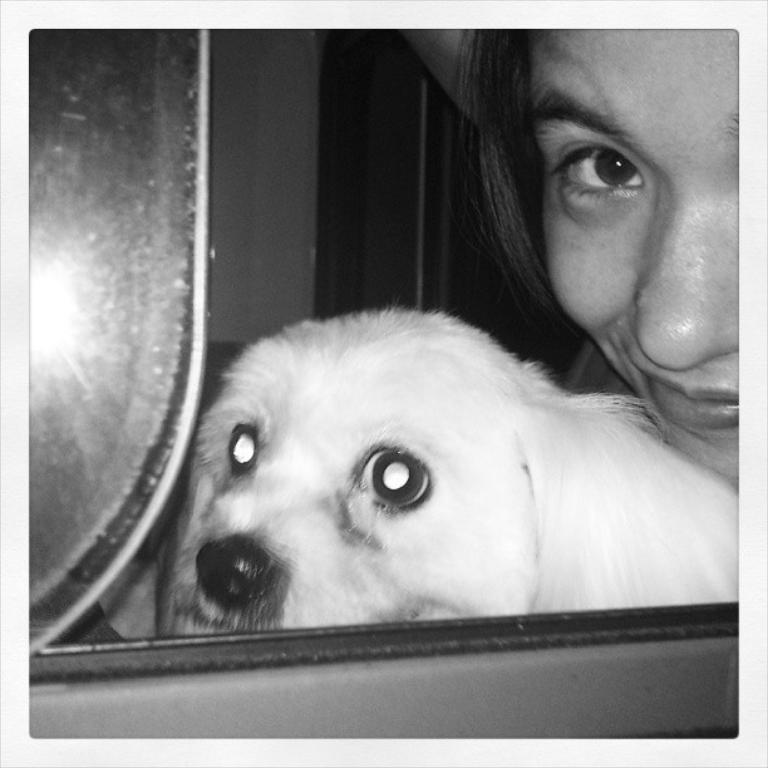What is the color scheme of the picture? The picture is black and white. What type of animal can be seen in the picture? There is a dog in the picture. What other subject is present in the picture besides the dog? There is a truncated face of a woman in the picture. What type of connection can be seen between the dog and the woman in the picture? There is no visible connection between the dog and the woman in the picture. What message of hope can be inferred from the picture? The picture does not convey any specific message of hope, as it only features a dog and a truncated face of a woman. 